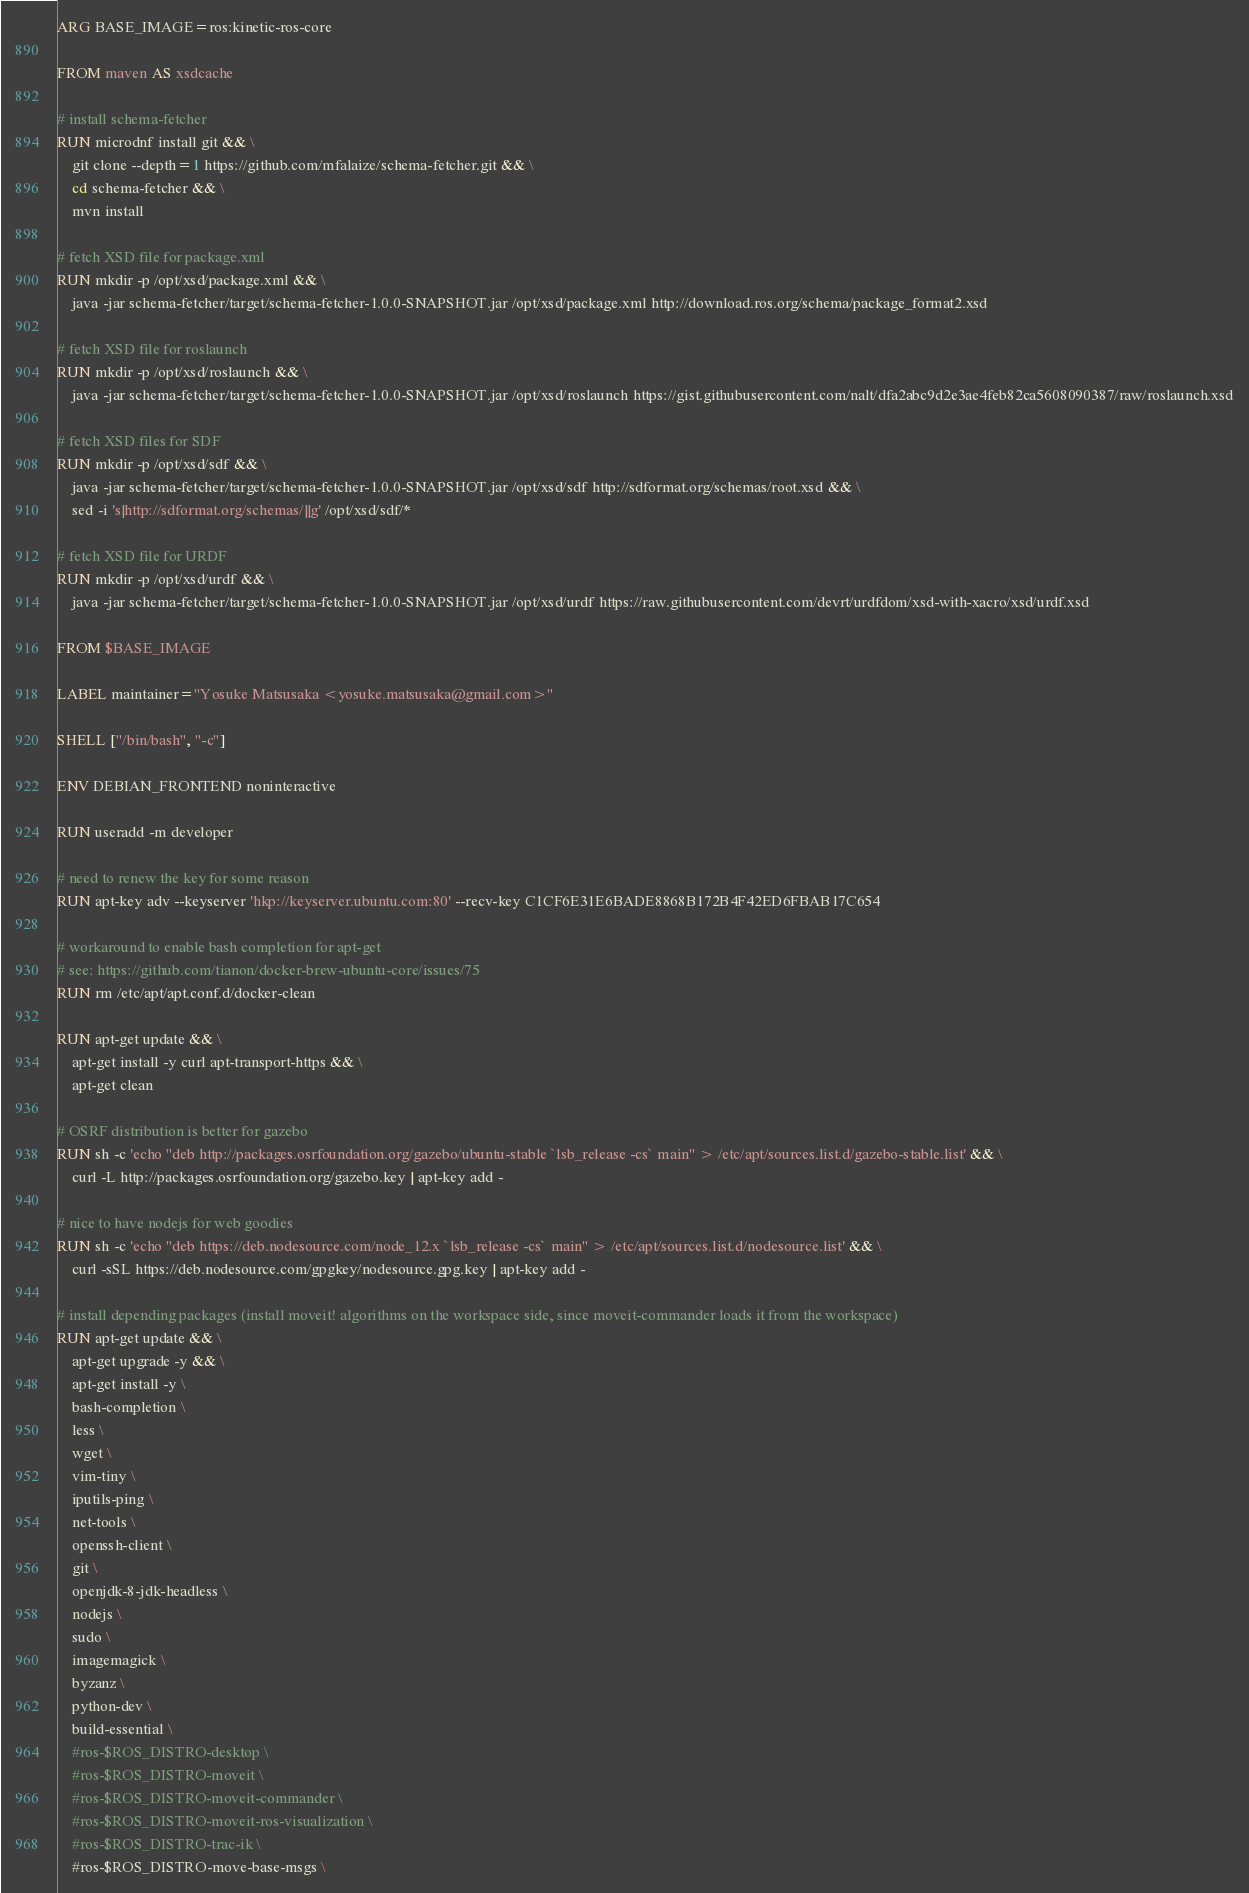<code> <loc_0><loc_0><loc_500><loc_500><_Dockerfile_>ARG BASE_IMAGE=ros:kinetic-ros-core

FROM maven AS xsdcache

# install schema-fetcher
RUN microdnf install git && \
    git clone --depth=1 https://github.com/mfalaize/schema-fetcher.git && \
    cd schema-fetcher && \
    mvn install

# fetch XSD file for package.xml
RUN mkdir -p /opt/xsd/package.xml && \
    java -jar schema-fetcher/target/schema-fetcher-1.0.0-SNAPSHOT.jar /opt/xsd/package.xml http://download.ros.org/schema/package_format2.xsd

# fetch XSD file for roslaunch
RUN mkdir -p /opt/xsd/roslaunch && \
    java -jar schema-fetcher/target/schema-fetcher-1.0.0-SNAPSHOT.jar /opt/xsd/roslaunch https://gist.githubusercontent.com/nalt/dfa2abc9d2e3ae4feb82ca5608090387/raw/roslaunch.xsd

# fetch XSD files for SDF
RUN mkdir -p /opt/xsd/sdf && \
    java -jar schema-fetcher/target/schema-fetcher-1.0.0-SNAPSHOT.jar /opt/xsd/sdf http://sdformat.org/schemas/root.xsd && \
    sed -i 's|http://sdformat.org/schemas/||g' /opt/xsd/sdf/*

# fetch XSD file for URDF
RUN mkdir -p /opt/xsd/urdf && \
    java -jar schema-fetcher/target/schema-fetcher-1.0.0-SNAPSHOT.jar /opt/xsd/urdf https://raw.githubusercontent.com/devrt/urdfdom/xsd-with-xacro/xsd/urdf.xsd

FROM $BASE_IMAGE

LABEL maintainer="Yosuke Matsusaka <yosuke.matsusaka@gmail.com>"

SHELL ["/bin/bash", "-c"]

ENV DEBIAN_FRONTEND noninteractive

RUN useradd -m developer

# need to renew the key for some reason
RUN apt-key adv --keyserver 'hkp://keyserver.ubuntu.com:80' --recv-key C1CF6E31E6BADE8868B172B4F42ED6FBAB17C654

# workaround to enable bash completion for apt-get
# see: https://github.com/tianon/docker-brew-ubuntu-core/issues/75
RUN rm /etc/apt/apt.conf.d/docker-clean

RUN apt-get update && \
    apt-get install -y curl apt-transport-https && \
    apt-get clean

# OSRF distribution is better for gazebo
RUN sh -c 'echo "deb http://packages.osrfoundation.org/gazebo/ubuntu-stable `lsb_release -cs` main" > /etc/apt/sources.list.d/gazebo-stable.list' && \
    curl -L http://packages.osrfoundation.org/gazebo.key | apt-key add -

# nice to have nodejs for web goodies
RUN sh -c 'echo "deb https://deb.nodesource.com/node_12.x `lsb_release -cs` main" > /etc/apt/sources.list.d/nodesource.list' && \
    curl -sSL https://deb.nodesource.com/gpgkey/nodesource.gpg.key | apt-key add -

# install depending packages (install moveit! algorithms on the workspace side, since moveit-commander loads it from the workspace)
RUN apt-get update && \
    apt-get upgrade -y && \
    apt-get install -y \
    bash-completion \
    less \
    wget \
    vim-tiny \
    iputils-ping \
    net-tools \
    openssh-client \
    git \
    openjdk-8-jdk-headless \
    nodejs \
    sudo \
    imagemagick \
    byzanz \
    python-dev \
    build-essential \
    #ros-$ROS_DISTRO-desktop \
    #ros-$ROS_DISTRO-moveit \
    #ros-$ROS_DISTRO-moveit-commander \
    #ros-$ROS_DISTRO-moveit-ros-visualization \
    #ros-$ROS_DISTRO-trac-ik \
    #ros-$ROS_DISTRO-move-base-msgs \</code> 